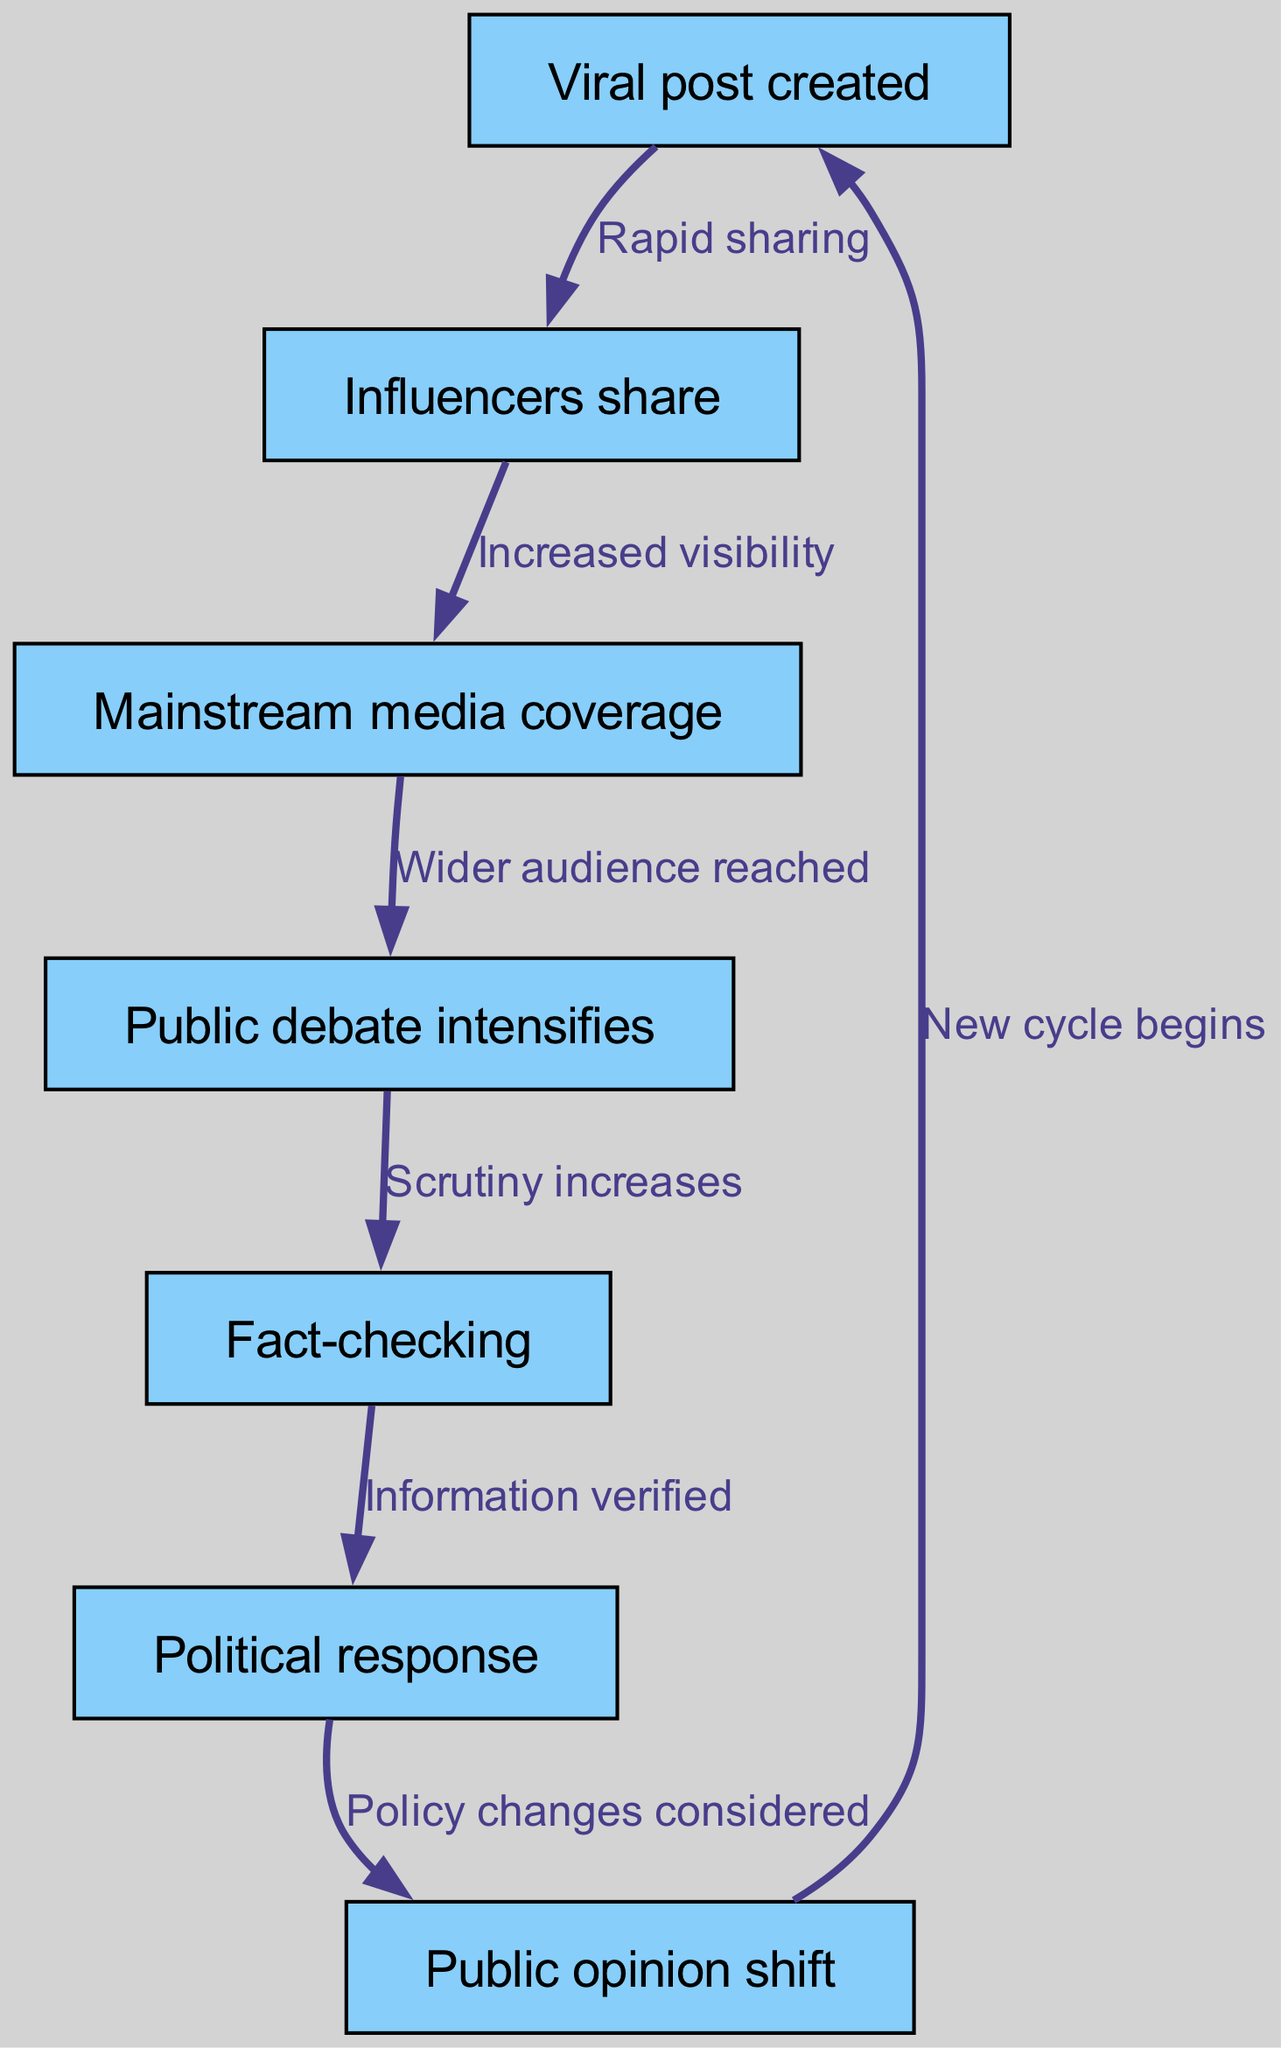What is the first step in the lifecycle? The diagram indicates that the first step or node in the lifecycle is “Viral post created,” which starts the entire process.
Answer: Viral post created How many nodes are depicted in this diagram? By counting each unique node listed, there are seven nodes shown in the diagram that represent the various stages of the lifecycle of a viral post.
Answer: Seven What action occurs after influencers share the post? According to the diagram, following the sharing by influencers, the next action is "Mainstream media coverage," indicating an expansion of the post's reach.
Answer: Mainstream media coverage What leads to an increase in public debate? The diagram specifies that "Wider audience reached," caused by "Mainstream media coverage," leads to intensified public debate, showing the flow from one node to the next.
Answer: Wider audience reached How does the process move from political response to public opinion shift? The diagram shows that after "Political response" (the sixth node), the outcome is a "Public opinion shift," highlighting the effect that political actions have on public perception.
Answer: Public opinion shift Which node signifies when scrutiny of the post increases? The node where scrutiny increases is "Public debate intensifies," indicating that during public discussions, there is a heightened examination of the viral post's content.
Answer: Public debate intensifies What is the final action that completes the cycle? The last action is indicated as "New cycle begins," which suggests that the aftermath of a public opinion shift creates conditions for further viral content creation.
Answer: New cycle begins What action follows fact-checking in the diagram? The diagram illustrates that after "Fact-checking," the next step is "Political response," emphasizing the relationship between verifying information and subsequent political actions.
Answer: Political response What connects the increase in visibility to influencer sharing? The edge labeled "Increased visibility" directly connects "Influencers share" (node two) to the preceding activity, showing how the sharing action magnifies the post's reach.
Answer: Increased visibility 